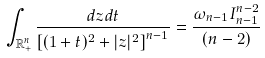Convert formula to latex. <formula><loc_0><loc_0><loc_500><loc_500>\int _ { \mathbb { R } _ { + } ^ { n } } \frac { d z d t } { \left [ ( 1 + t ) ^ { 2 } + | z | ^ { 2 } \right ] ^ { n - 1 } } = \frac { \omega _ { n - 1 } I _ { n - 1 } ^ { n - 2 } } { ( n - 2 ) }</formula> 